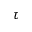<formula> <loc_0><loc_0><loc_500><loc_500>\tau</formula> 